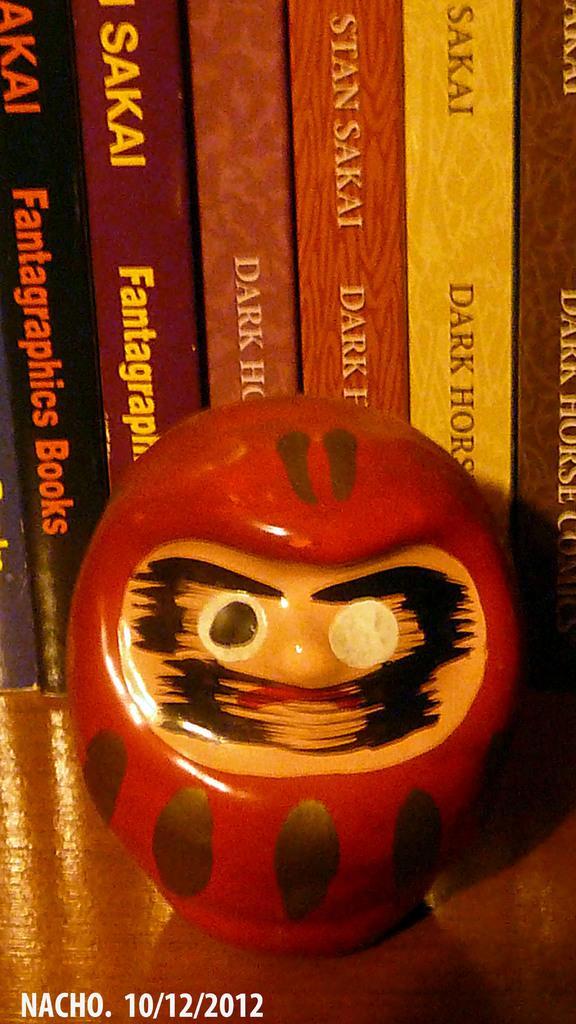How would you summarize this image in a sentence or two? In this picture we can see books in the background, there is an object present in the front, we can see some text on these books, at the left bottom we can see date, month and year. 